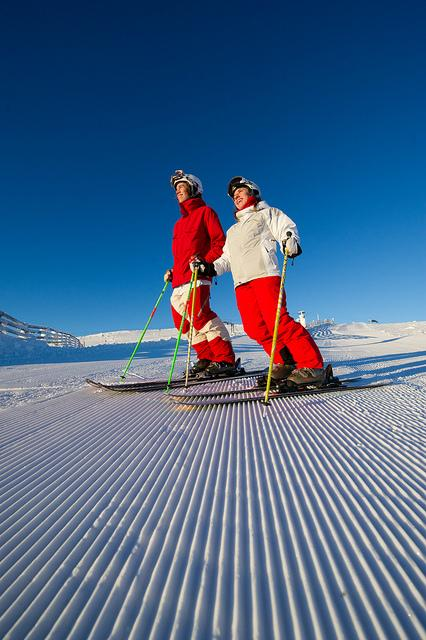How did these grooves get set in snow? Please explain your reasoning. snow groomer. They reach there by using snow groomer. 